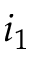<formula> <loc_0><loc_0><loc_500><loc_500>i _ { 1 }</formula> 